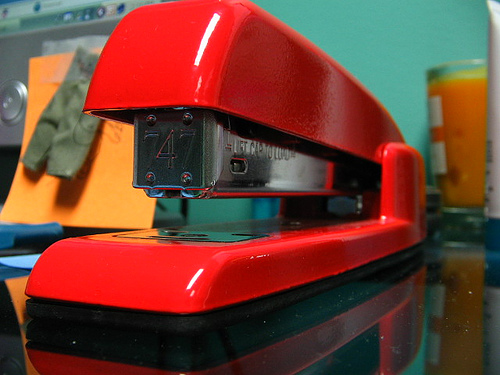<image>
Can you confirm if the stapler is above the table? No. The stapler is not positioned above the table. The vertical arrangement shows a different relationship. 